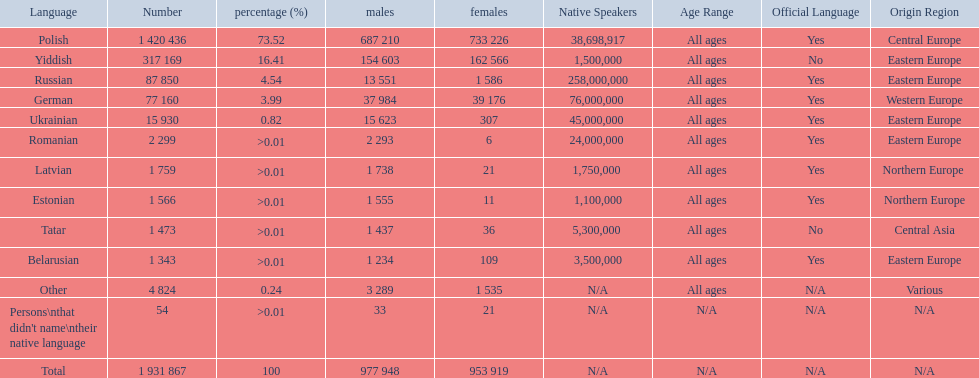Number of male russian speakers 13 551. 